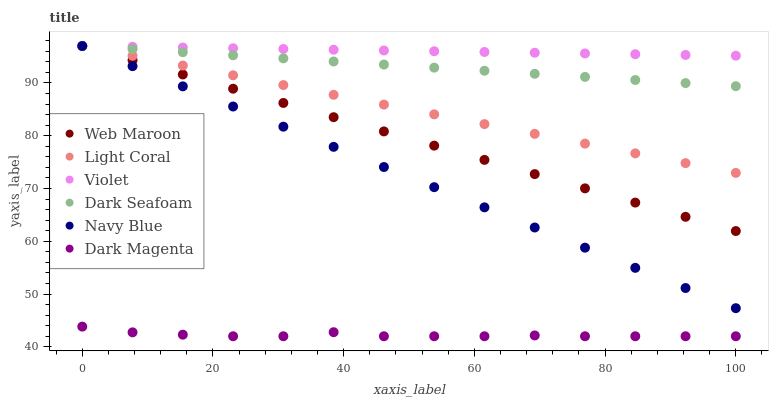Does Dark Magenta have the minimum area under the curve?
Answer yes or no. Yes. Does Violet have the maximum area under the curve?
Answer yes or no. Yes. Does Navy Blue have the minimum area under the curve?
Answer yes or no. No. Does Navy Blue have the maximum area under the curve?
Answer yes or no. No. Is Dark Seafoam the smoothest?
Answer yes or no. Yes. Is Dark Magenta the roughest?
Answer yes or no. Yes. Is Navy Blue the smoothest?
Answer yes or no. No. Is Navy Blue the roughest?
Answer yes or no. No. Does Dark Magenta have the lowest value?
Answer yes or no. Yes. Does Navy Blue have the lowest value?
Answer yes or no. No. Does Violet have the highest value?
Answer yes or no. Yes. Is Dark Magenta less than Web Maroon?
Answer yes or no. Yes. Is Navy Blue greater than Dark Magenta?
Answer yes or no. Yes. Does Dark Seafoam intersect Navy Blue?
Answer yes or no. Yes. Is Dark Seafoam less than Navy Blue?
Answer yes or no. No. Is Dark Seafoam greater than Navy Blue?
Answer yes or no. No. Does Dark Magenta intersect Web Maroon?
Answer yes or no. No. 